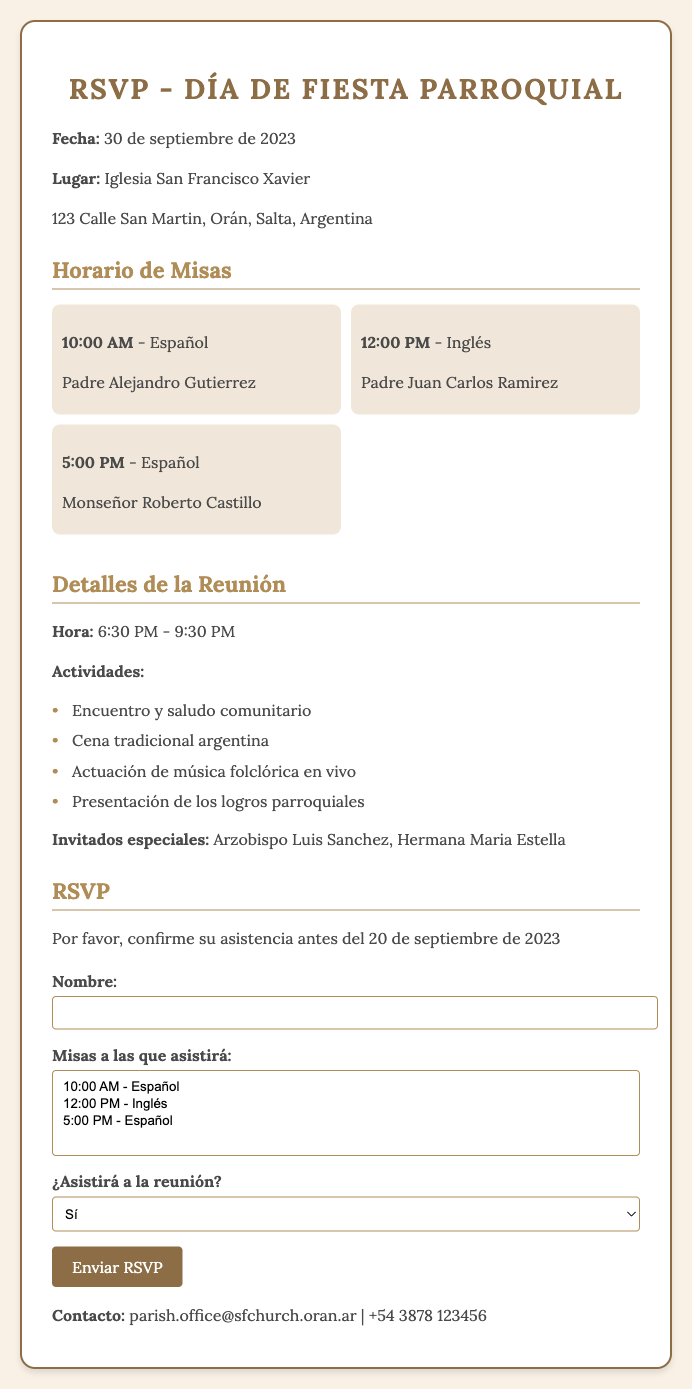¿Qué fecha es el Día de Fiesta Parroquial? La fecha está claramente indicada en el documento.
Answer: 30 de septiembre de 2023 ¿A qué hora empieza la reunión? La hora del inicio de la reunión se menciona en la sección correspondiente.
Answer: 6:30 PM ¿Cuántas Misas hay programadas? La información de las Misas se presenta en la sección de horario de Misas.
Answer: 3 ¿Quién oficia la Misa de las 12:00 PM? El documento menciona los nombres de los sacerdotes para cada Misa.
Answer: Padre Juan Carlos Ramirez ¿Es obligatoria la confirmación de asistencia? El texto solicita que se confirme la asistencia, indicando su importancia.
Answer: Sí ¿Qué tipo de cena se servirá en la reunión? Se detalla un aspecto específico de la actividad de la reunión.
Answer: Cena tradicional argentina ¿Hasta cuándo se pueden enviar respuestas para el RSVP? La fecha límite para el RSVP se menciona explícitamente en el documento.
Answer: 20 de septiembre de 2023 ¿Quiénes son los invitados especiales? Se especifica quiénes serán los invitados especiales en la reunión.
Answer: Arzobispo Luis Sanchez, Hermana Maria Estella ¿Cuál es el lugar del evento? El lugar está claramente indicado en la información de ubicación.
Answer: Iglesia San Francisco Xavier 